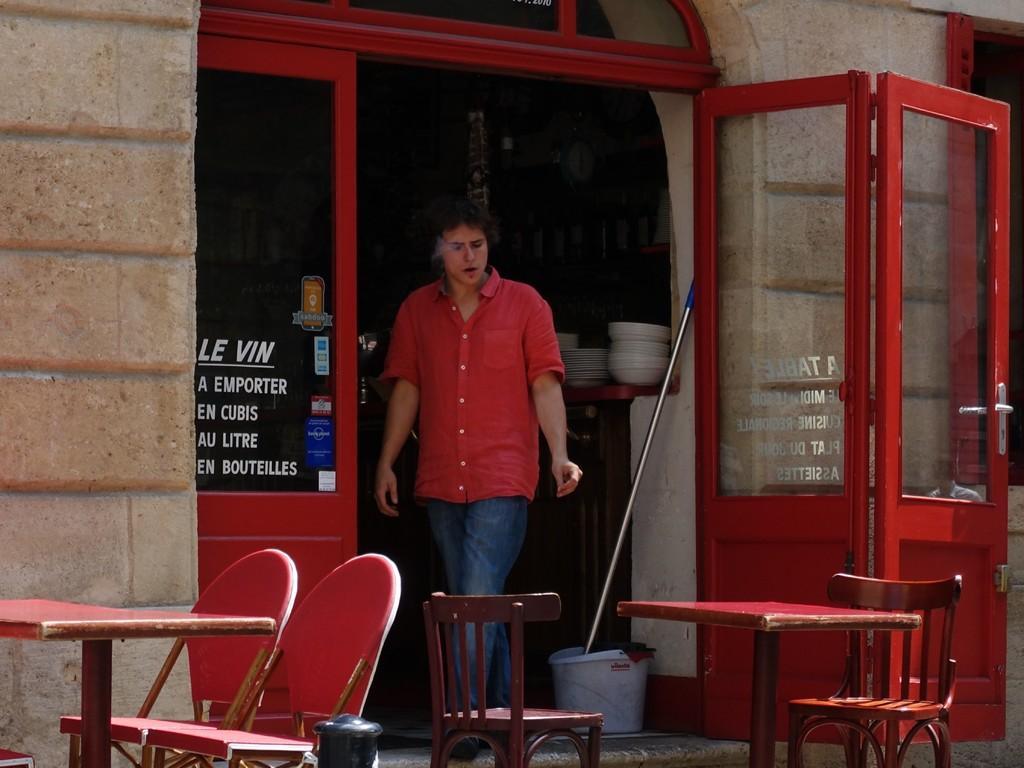Could you give a brief overview of what you see in this image? In the middle a man is smoking cigarette behind the tables and chairs and behind him there are plates,bucket,doors. 